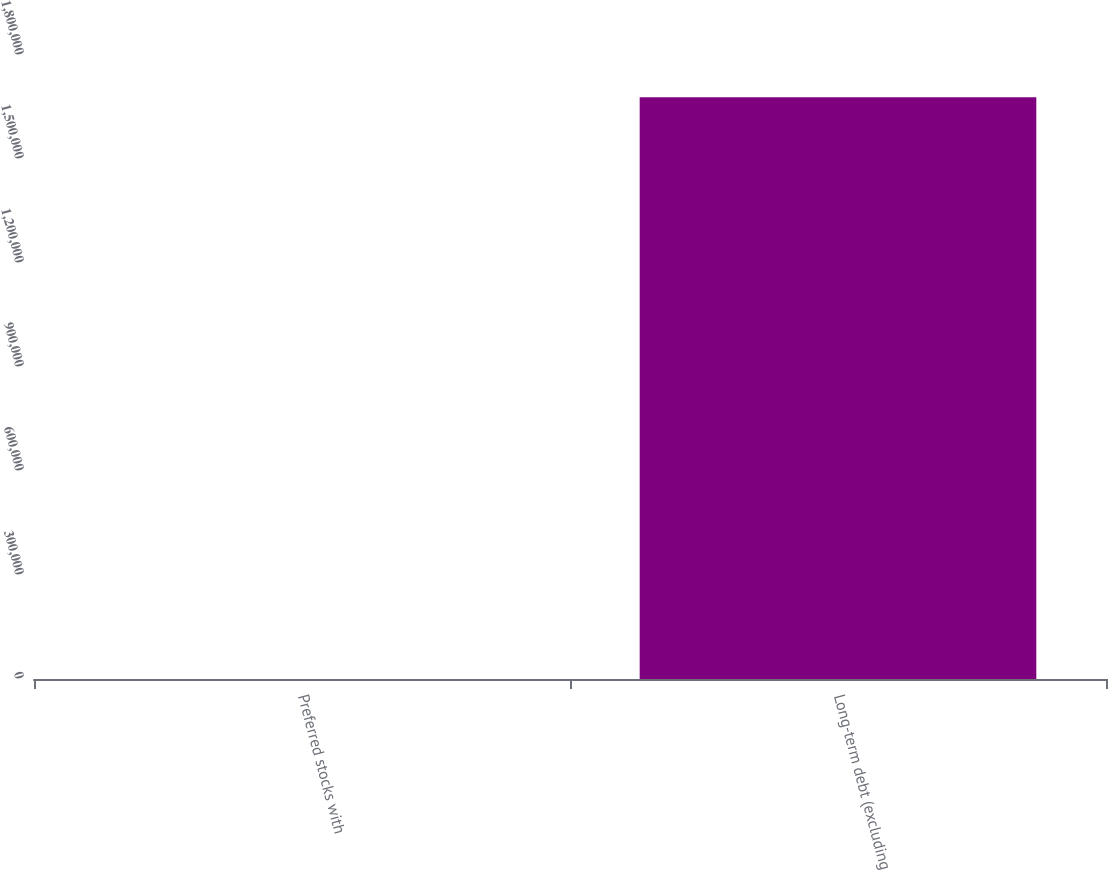Convert chart. <chart><loc_0><loc_0><loc_500><loc_500><bar_chart><fcel>Preferred stocks with<fcel>Long-term debt (excluding<nl><fcel>3.85<fcel>1.67778e+06<nl></chart> 